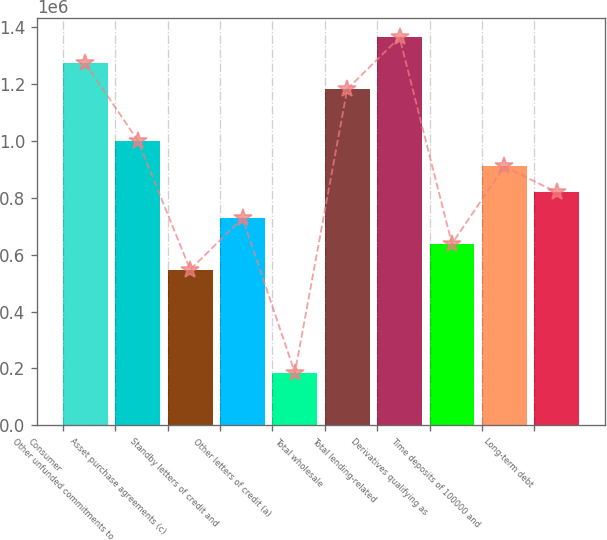Convert chart. <chart><loc_0><loc_0><loc_500><loc_500><bar_chart><fcel>Consumer<fcel>Other unfunded commitments to<fcel>Asset purchase agreements (c)<fcel>Standby letters of credit and<fcel>Other letters of credit (a)<fcel>Total wholesale<fcel>Total lending-related<fcel>Derivatives qualifying as<fcel>Time deposits of 100000 and<fcel>Long-term debt<nl><fcel>1.27374e+06<fcel>1.00138e+06<fcel>547454<fcel>729024<fcel>184313<fcel>1.18295e+06<fcel>1.36452e+06<fcel>638239<fcel>910595<fcel>819810<nl></chart> 